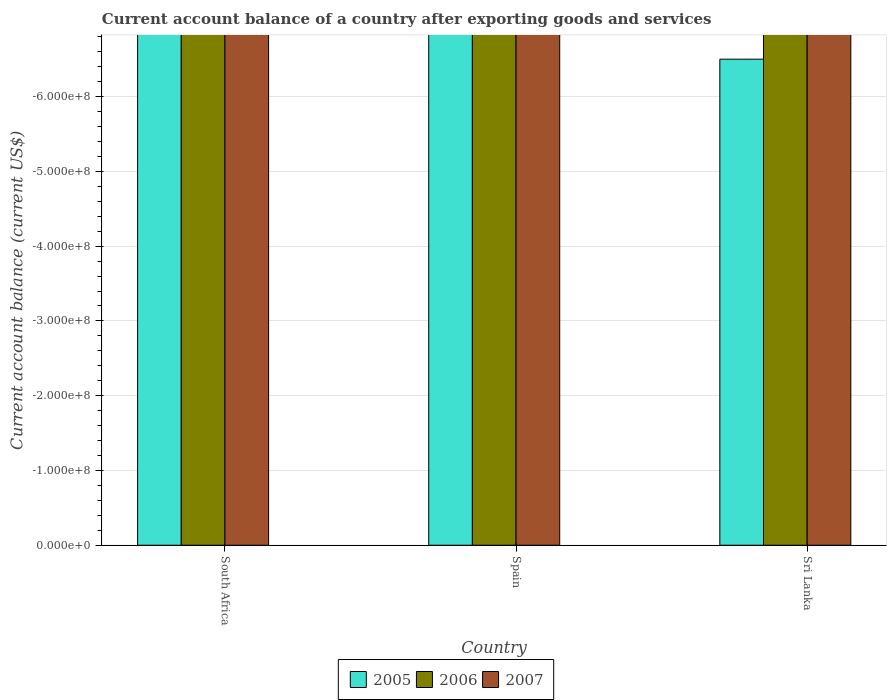How many different coloured bars are there?
Provide a succinct answer. 0. Are the number of bars per tick equal to the number of legend labels?
Your answer should be very brief. No. How many bars are there on the 3rd tick from the right?
Make the answer very short. 0. What is the label of the 3rd group of bars from the left?
Provide a short and direct response. Sri Lanka. In how many cases, is the number of bars for a given country not equal to the number of legend labels?
Your answer should be compact. 3. What is the account balance in 2007 in Sri Lanka?
Your response must be concise. 0. Across all countries, what is the minimum account balance in 2006?
Your response must be concise. 0. What is the total account balance in 2005 in the graph?
Your answer should be compact. 0. What is the difference between the account balance in 2007 in South Africa and the account balance in 2006 in Sri Lanka?
Your response must be concise. 0. In how many countries, is the account balance in 2006 greater than the average account balance in 2006 taken over all countries?
Make the answer very short. 0. Is it the case that in every country, the sum of the account balance in 2005 and account balance in 2006 is greater than the account balance in 2007?
Provide a short and direct response. No. How many bars are there?
Your response must be concise. 0. How many countries are there in the graph?
Keep it short and to the point. 3. What is the difference between two consecutive major ticks on the Y-axis?
Offer a very short reply. 1.00e+08. Does the graph contain grids?
Keep it short and to the point. Yes. What is the title of the graph?
Offer a terse response. Current account balance of a country after exporting goods and services. What is the label or title of the Y-axis?
Keep it short and to the point. Current account balance (current US$). What is the Current account balance (current US$) of 2005 in South Africa?
Offer a very short reply. 0. What is the Current account balance (current US$) in 2006 in South Africa?
Give a very brief answer. 0. What is the Current account balance (current US$) in 2007 in South Africa?
Your response must be concise. 0. What is the Current account balance (current US$) of 2006 in Spain?
Give a very brief answer. 0. What is the Current account balance (current US$) in 2006 in Sri Lanka?
Give a very brief answer. 0. What is the Current account balance (current US$) of 2007 in Sri Lanka?
Provide a succinct answer. 0. What is the total Current account balance (current US$) of 2005 in the graph?
Make the answer very short. 0. What is the total Current account balance (current US$) in 2006 in the graph?
Keep it short and to the point. 0. 